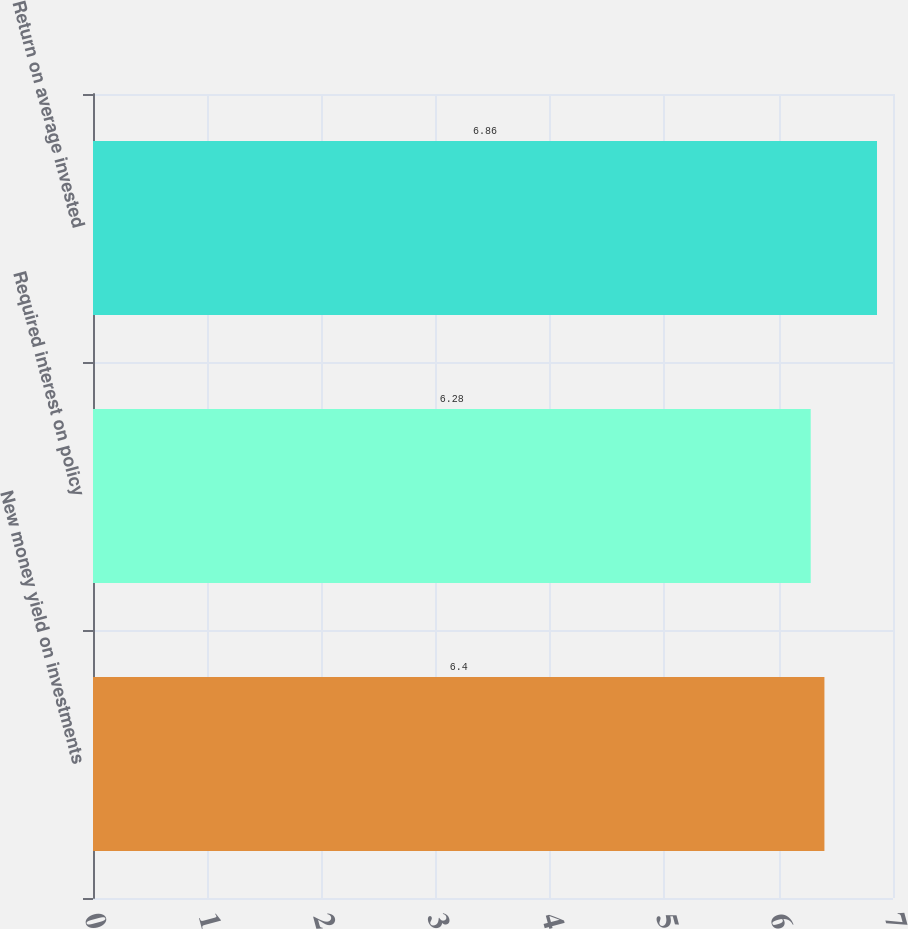<chart> <loc_0><loc_0><loc_500><loc_500><bar_chart><fcel>New money yield on investments<fcel>Required interest on policy<fcel>Return on average invested<nl><fcel>6.4<fcel>6.28<fcel>6.86<nl></chart> 